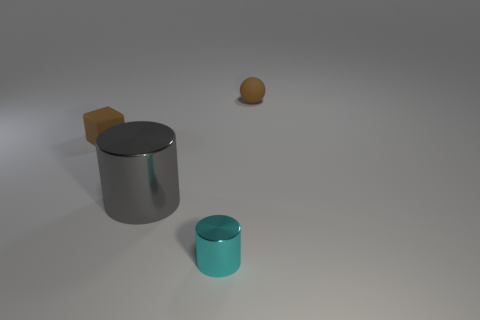Add 4 yellow metallic objects. How many objects exist? 8 Subtract all cyan cylinders. How many cylinders are left? 1 Subtract all balls. How many objects are left? 3 Subtract all cyan matte cubes. Subtract all brown rubber objects. How many objects are left? 2 Add 2 big things. How many big things are left? 3 Add 2 brown matte balls. How many brown matte balls exist? 3 Subtract 0 green spheres. How many objects are left? 4 Subtract all green spheres. Subtract all yellow cubes. How many spheres are left? 1 